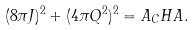<formula> <loc_0><loc_0><loc_500><loc_500>( 8 \pi J ) ^ { 2 } + ( 4 \pi Q ^ { 2 } ) ^ { 2 } = A _ { C } H A .</formula> 